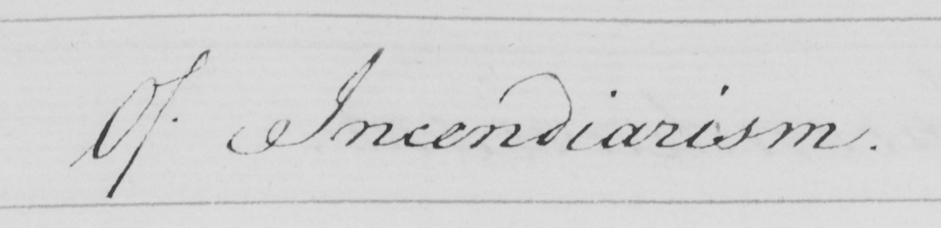What does this handwritten line say? Of Incendiarism . 